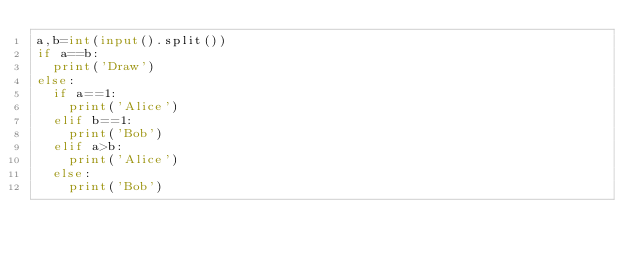Convert code to text. <code><loc_0><loc_0><loc_500><loc_500><_Python_>a,b=int(input().split())
if a==b:
  print('Draw')
else:
  if a==1:
    print('Alice')
  elif b==1:
    print('Bob')
  elif a>b:
    print('Alice')
  else:
    print('Bob')</code> 